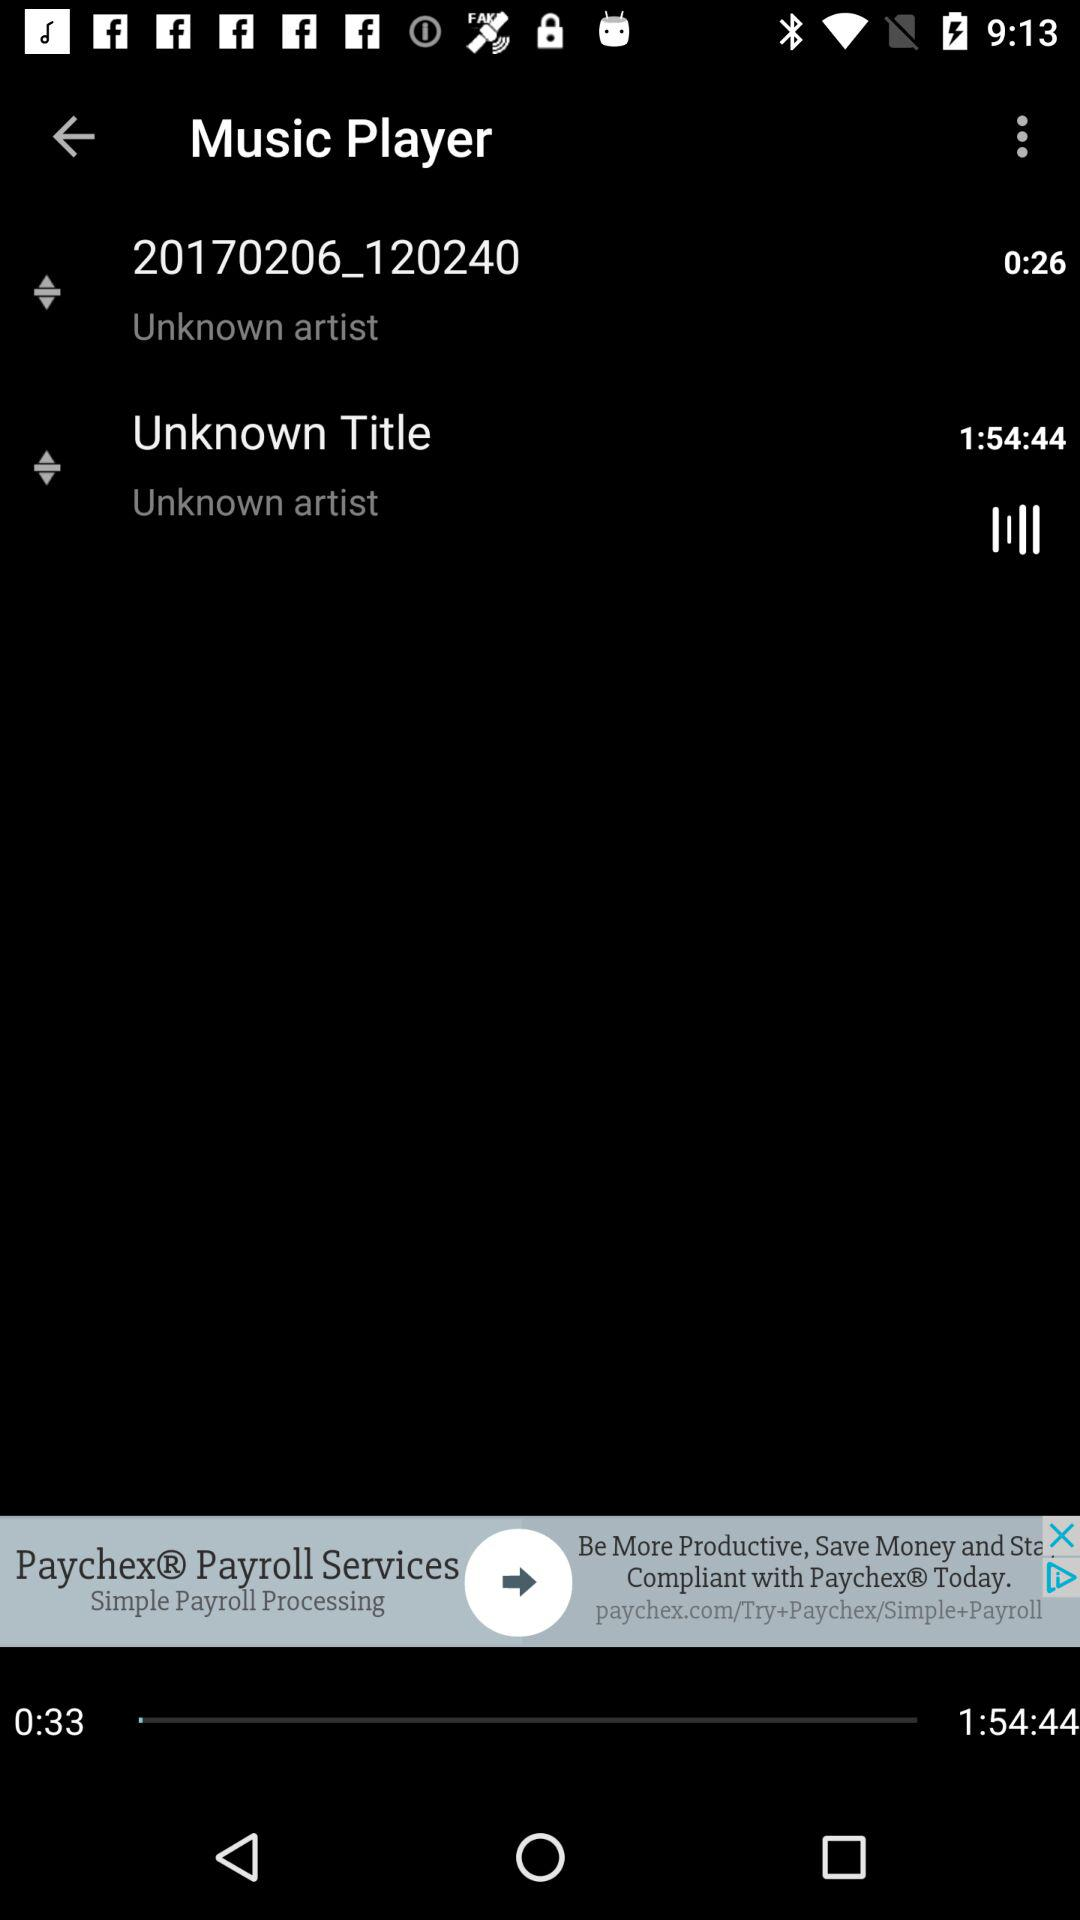For how long has the "Unknown Title" music been played? The "Unknown Title" music has been played for 33 seconds. 